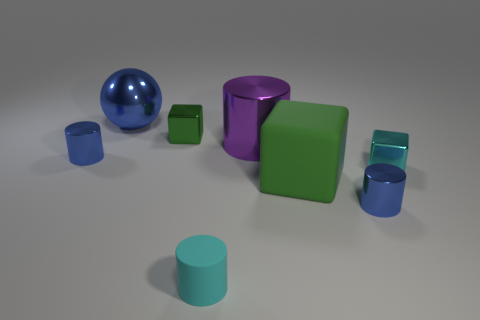Add 1 tiny blue metal objects. How many objects exist? 9 Subtract all metal cubes. How many cubes are left? 1 Subtract all cyan cylinders. How many cylinders are left? 3 Subtract 0 brown spheres. How many objects are left? 8 Subtract all spheres. How many objects are left? 7 Subtract 1 cubes. How many cubes are left? 2 Subtract all green cylinders. Subtract all yellow spheres. How many cylinders are left? 4 Subtract all green cylinders. How many cyan spheres are left? 0 Subtract all big green matte things. Subtract all cyan metallic cubes. How many objects are left? 6 Add 1 small cyan matte things. How many small cyan matte things are left? 2 